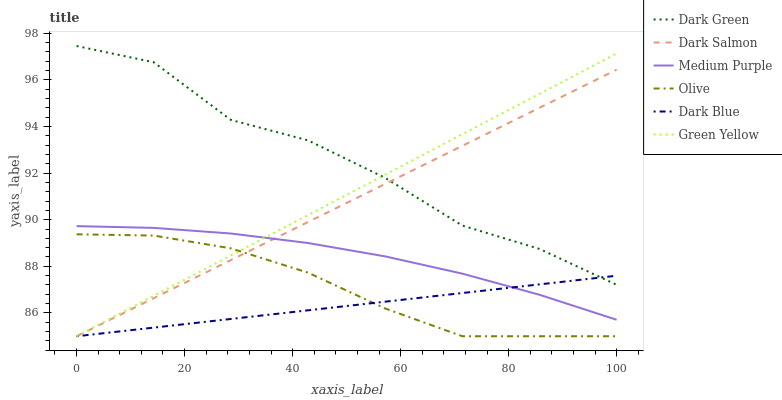Does Dark Blue have the minimum area under the curve?
Answer yes or no. Yes. Does Dark Green have the maximum area under the curve?
Answer yes or no. Yes. Does Medium Purple have the minimum area under the curve?
Answer yes or no. No. Does Medium Purple have the maximum area under the curve?
Answer yes or no. No. Is Green Yellow the smoothest?
Answer yes or no. Yes. Is Dark Green the roughest?
Answer yes or no. Yes. Is Medium Purple the smoothest?
Answer yes or no. No. Is Medium Purple the roughest?
Answer yes or no. No. Does Dark Salmon have the lowest value?
Answer yes or no. Yes. Does Medium Purple have the lowest value?
Answer yes or no. No. Does Dark Green have the highest value?
Answer yes or no. Yes. Does Medium Purple have the highest value?
Answer yes or no. No. Is Medium Purple less than Dark Green?
Answer yes or no. Yes. Is Dark Green greater than Medium Purple?
Answer yes or no. Yes. Does Dark Salmon intersect Olive?
Answer yes or no. Yes. Is Dark Salmon less than Olive?
Answer yes or no. No. Is Dark Salmon greater than Olive?
Answer yes or no. No. Does Medium Purple intersect Dark Green?
Answer yes or no. No. 